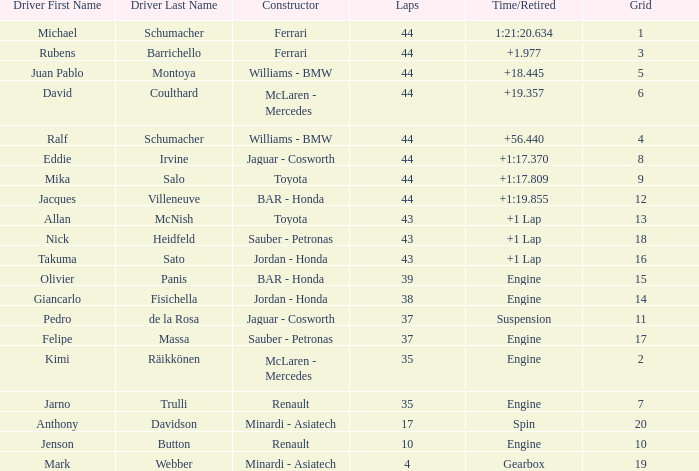What was the retired time on someone who had 43 laps on a grip of 18? +1 Lap. 